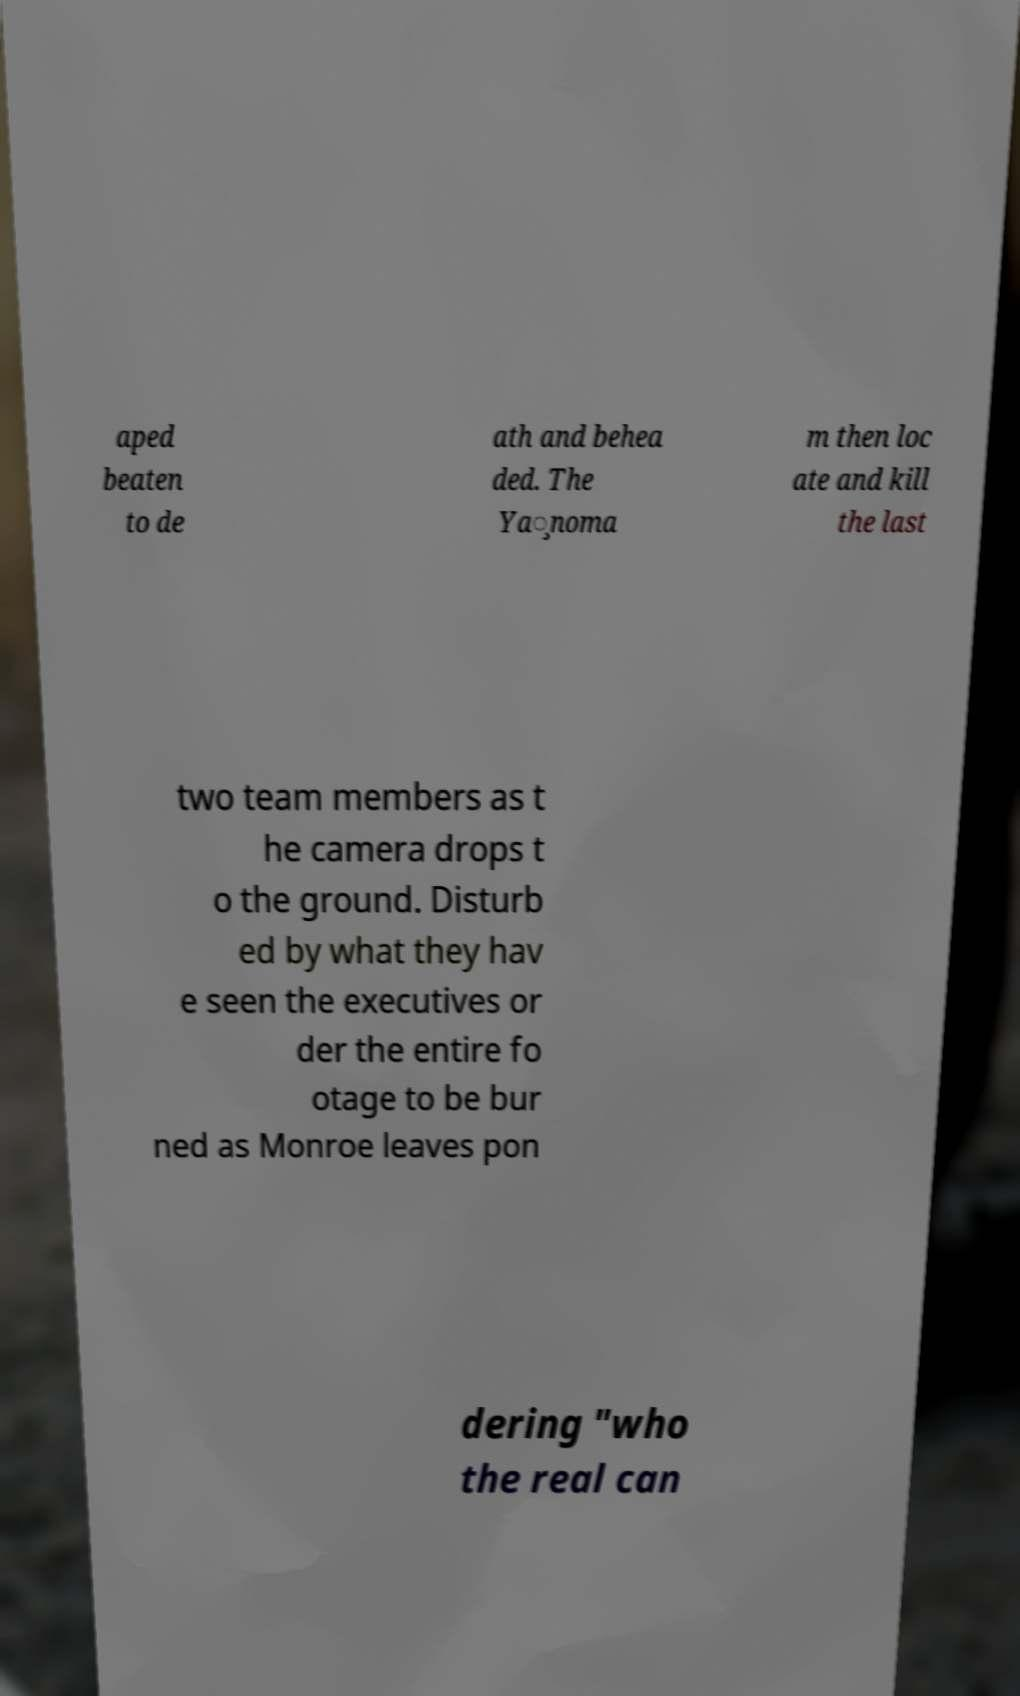What messages or text are displayed in this image? I need them in a readable, typed format. aped beaten to de ath and behea ded. The Ya̧noma m then loc ate and kill the last two team members as t he camera drops t o the ground. Disturb ed by what they hav e seen the executives or der the entire fo otage to be bur ned as Monroe leaves pon dering "who the real can 